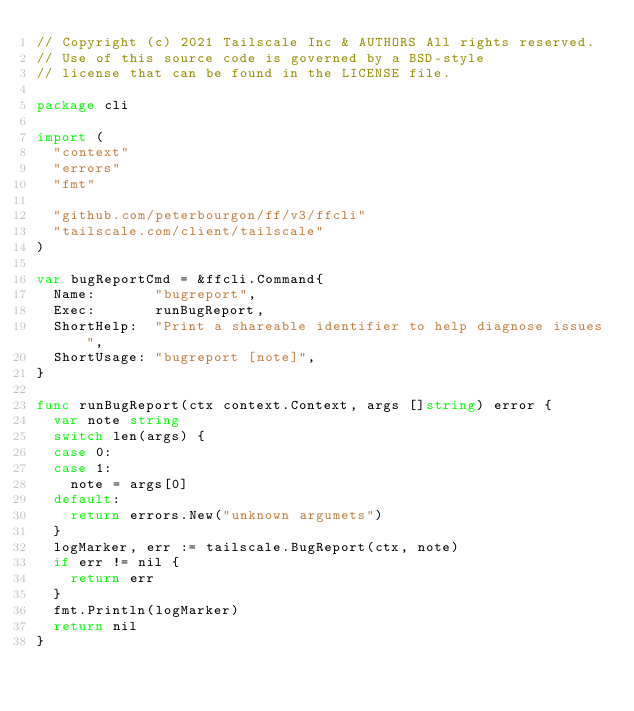<code> <loc_0><loc_0><loc_500><loc_500><_Go_>// Copyright (c) 2021 Tailscale Inc & AUTHORS All rights reserved.
// Use of this source code is governed by a BSD-style
// license that can be found in the LICENSE file.

package cli

import (
	"context"
	"errors"
	"fmt"

	"github.com/peterbourgon/ff/v3/ffcli"
	"tailscale.com/client/tailscale"
)

var bugReportCmd = &ffcli.Command{
	Name:       "bugreport",
	Exec:       runBugReport,
	ShortHelp:  "Print a shareable identifier to help diagnose issues",
	ShortUsage: "bugreport [note]",
}

func runBugReport(ctx context.Context, args []string) error {
	var note string
	switch len(args) {
	case 0:
	case 1:
		note = args[0]
	default:
		return errors.New("unknown argumets")
	}
	logMarker, err := tailscale.BugReport(ctx, note)
	if err != nil {
		return err
	}
	fmt.Println(logMarker)
	return nil
}
</code> 